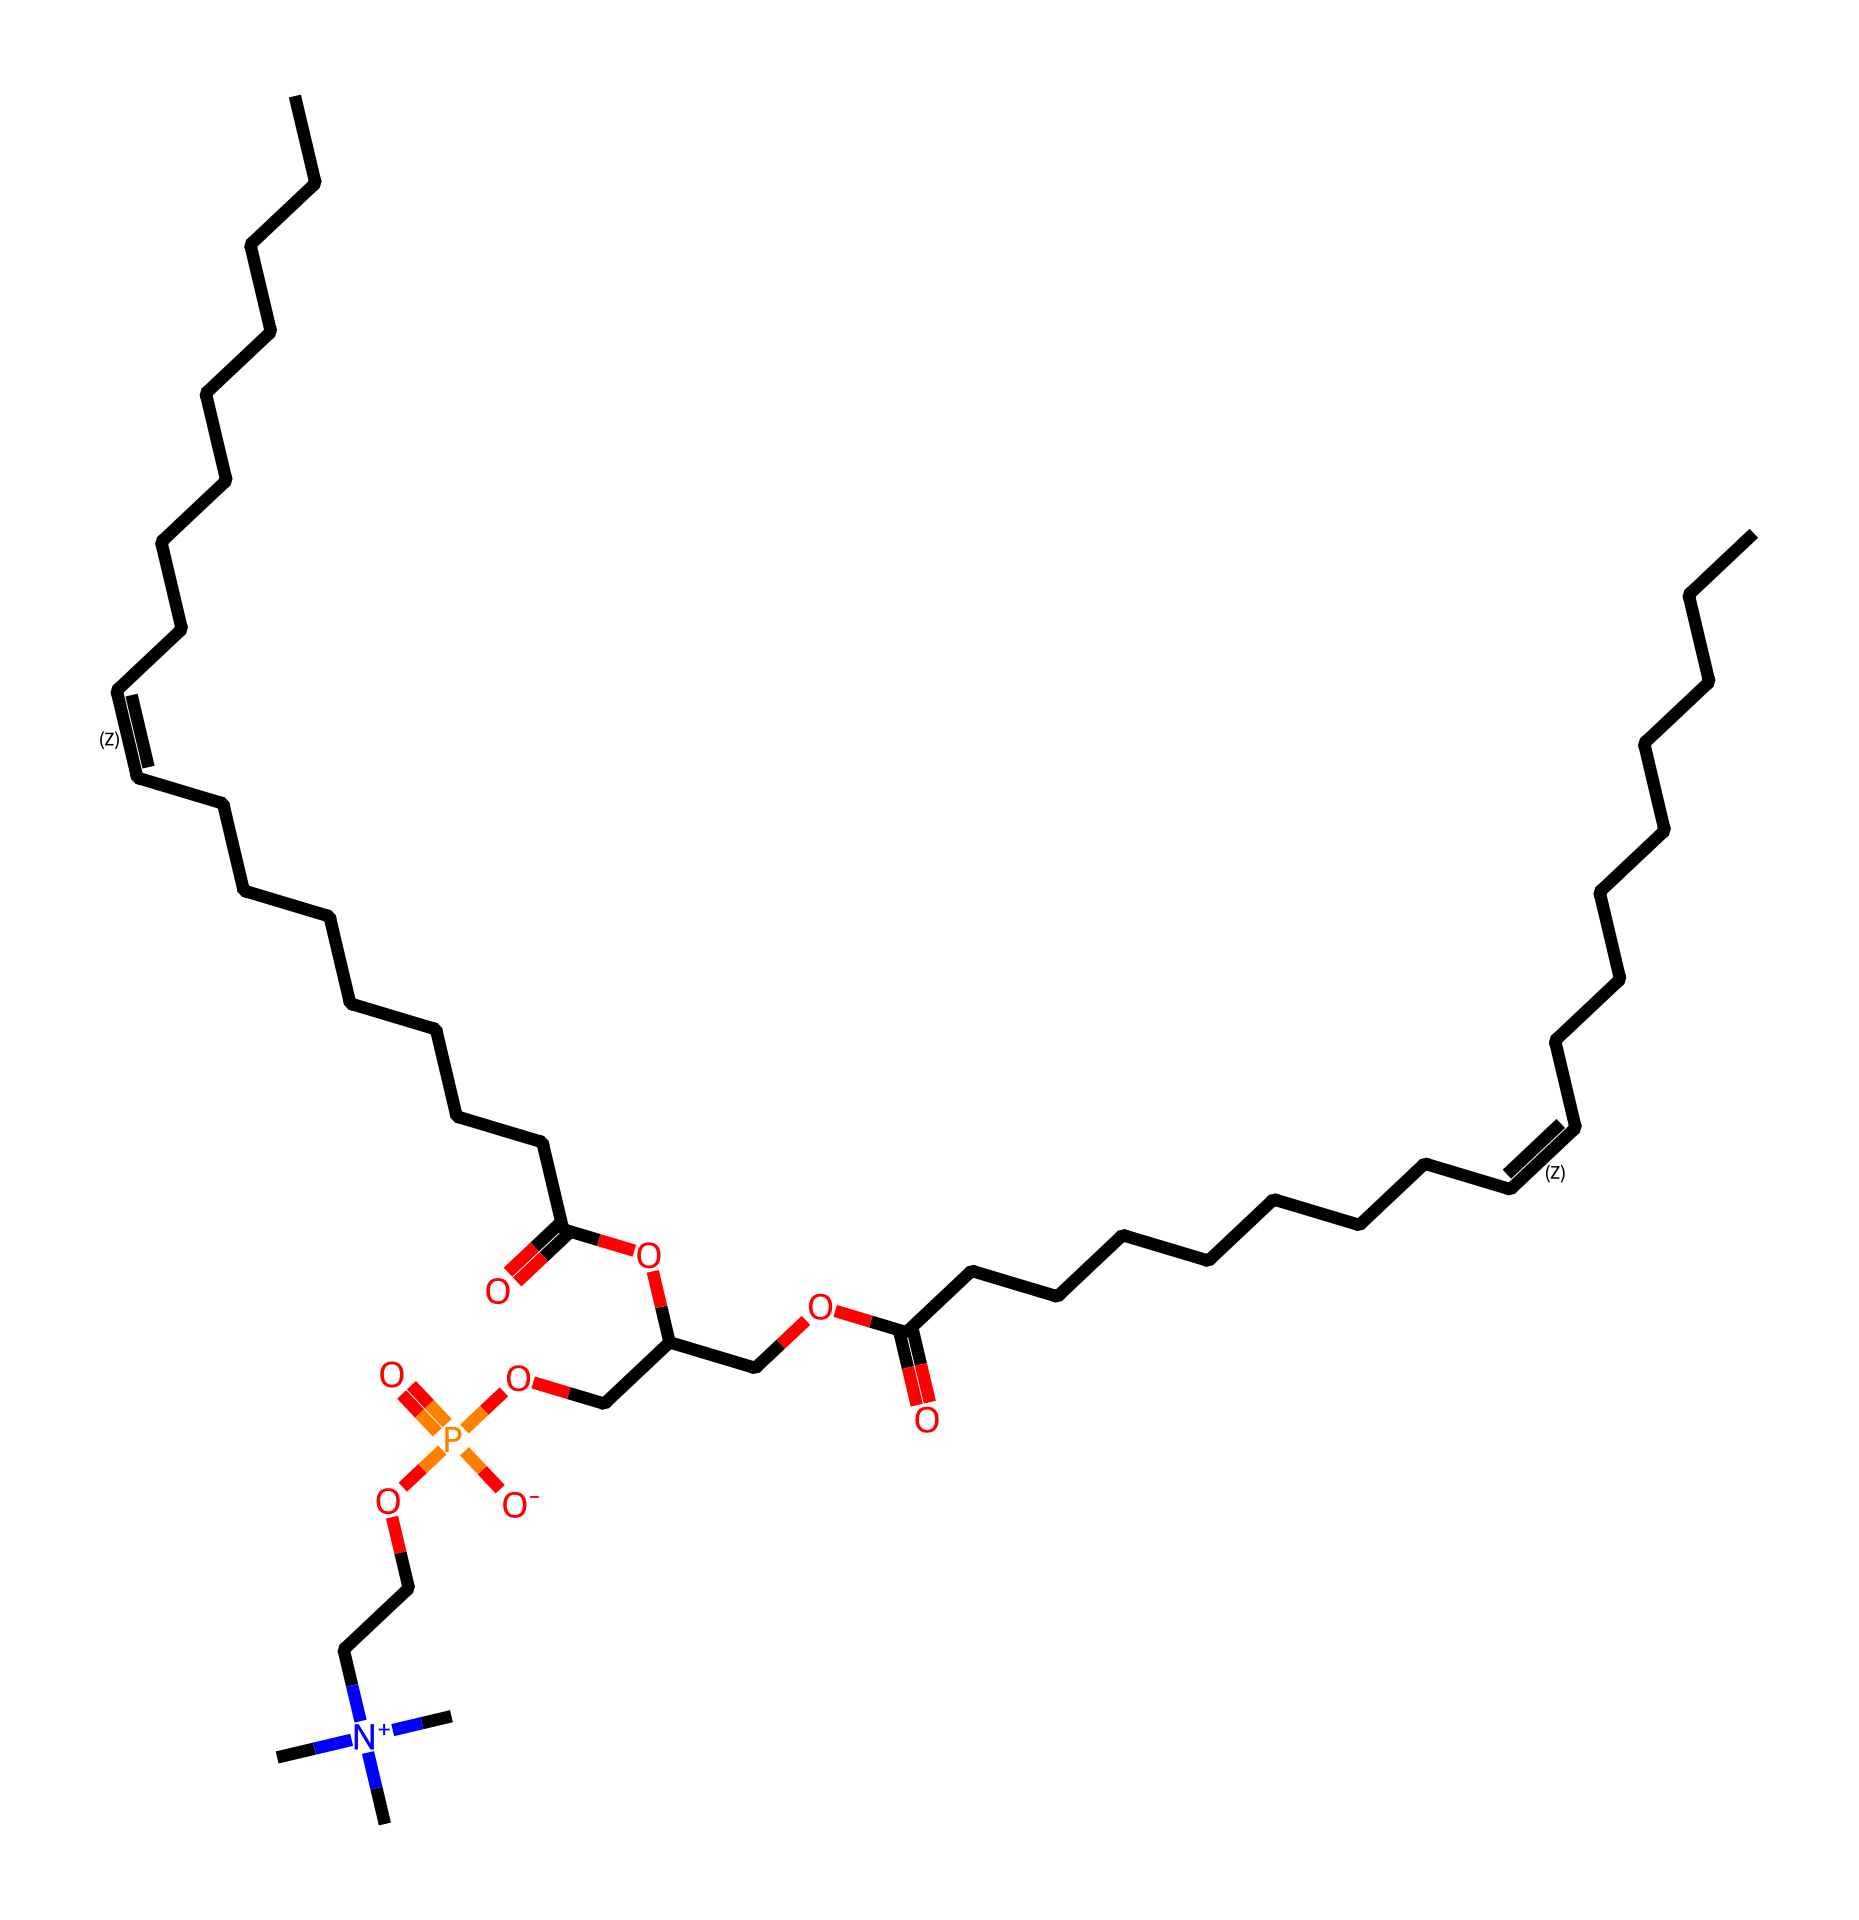what type of surfactant is lecithin? Lecithin is a phospholipid, which is a type of surfactant characterized by having both hydrophobic and hydrophilic properties. This is evident from its structure, which includes a hydrophilic phosphate group and hydrophobic fatty acid chains.
Answer: phospholipid how many carbon atoms are in lecithin? By analyzing the provided SMILES representation, we can count the number of carbon atoms. The structure indicates a long hydrocarbon chain and includes other carbon-containing functionalities, leading to a total of more than 20 carbon atoms.
Answer: 28 what functional groups are present in lecithin? Lecithin contains several functional groups. The key ones identified from the SMILES structure include carboxylic acids (from the -COOH), esters (shown as -O- connections), and phosphates (-PO4).
Answer: carboxylic acid, ester, phosphate how many ester linkages are present in lecithin? Searching the SMILES notation reveals two ester linkages. One occurs between the fatty acid chain and the alcohol (glycerol), and the other is part of the phospholipid structure with the phosphate group, indicating two esteric connections.
Answer: 2 what role does lecithin play in paper coatings for manga? Lecithin acts as an emulsifier, helping to blend water and oil-based materials in the coatings. Its surfactant properties allow uniform dispersion, improving the smoothness and quality of ink application on paper.
Answer: emulsifier what is the significance of double bonds in lecithin's structure? The presence of double bonds in lecithin's fatty acid chains contributes to its fluidity and flexibility. This impacts the interaction with other molecules, enhancing the surfacing properties needed for effective ink transfer in paper coatings.
Answer: fluidity 